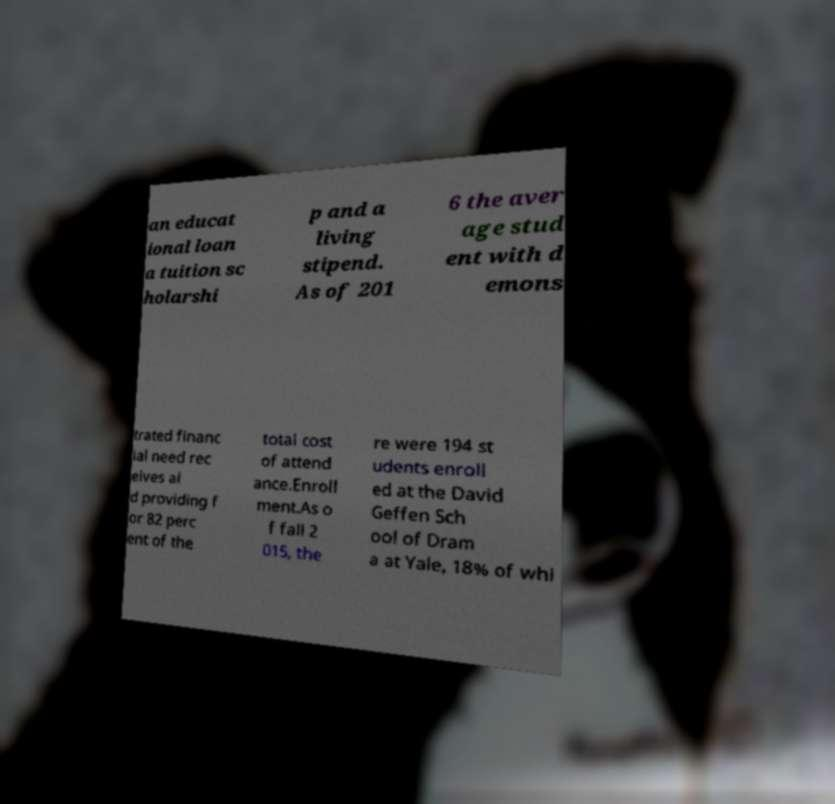Can you accurately transcribe the text from the provided image for me? an educat ional loan a tuition sc holarshi p and a living stipend. As of 201 6 the aver age stud ent with d emons trated financ ial need rec eives ai d providing f or 82 perc ent of the total cost of attend ance.Enroll ment.As o f fall 2 015, the re were 194 st udents enroll ed at the David Geffen Sch ool of Dram a at Yale, 18% of whi 